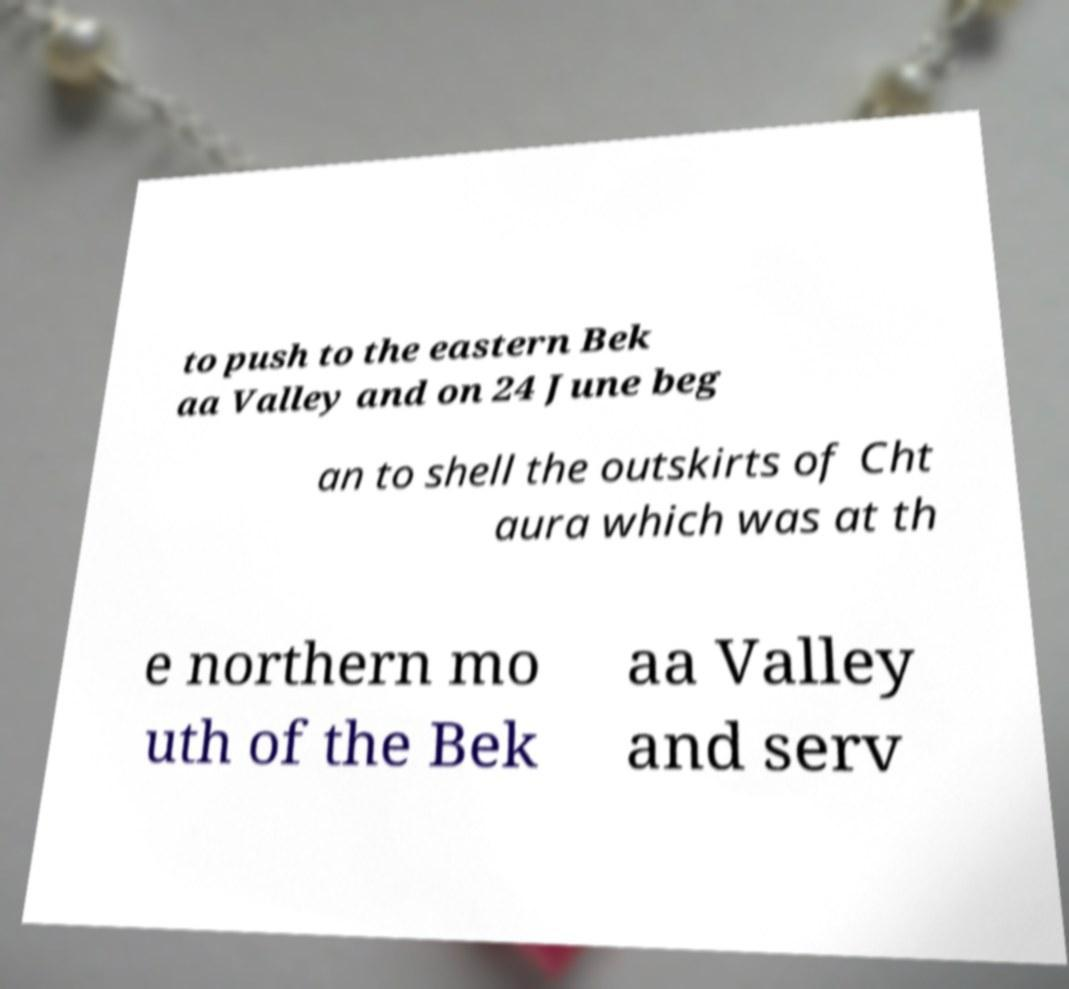Can you accurately transcribe the text from the provided image for me? to push to the eastern Bek aa Valley and on 24 June beg an to shell the outskirts of Cht aura which was at th e northern mo uth of the Bek aa Valley and serv 